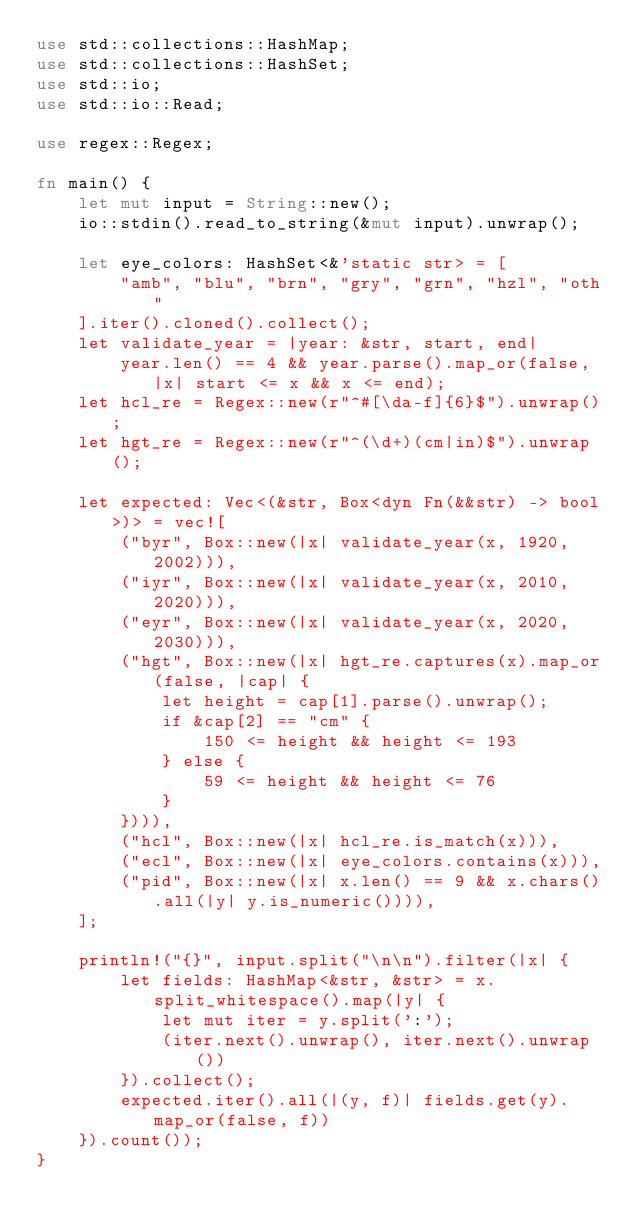Convert code to text. <code><loc_0><loc_0><loc_500><loc_500><_Rust_>use std::collections::HashMap;
use std::collections::HashSet;
use std::io;
use std::io::Read;

use regex::Regex;

fn main() {
    let mut input = String::new();
    io::stdin().read_to_string(&mut input).unwrap();

    let eye_colors: HashSet<&'static str> = [
        "amb", "blu", "brn", "gry", "grn", "hzl", "oth"
    ].iter().cloned().collect();
    let validate_year = |year: &str, start, end| 
        year.len() == 4 && year.parse().map_or(false, |x| start <= x && x <= end);
    let hcl_re = Regex::new(r"^#[\da-f]{6}$").unwrap();
    let hgt_re = Regex::new(r"^(\d+)(cm|in)$").unwrap();

    let expected: Vec<(&str, Box<dyn Fn(&&str) -> bool>)> = vec![
        ("byr", Box::new(|x| validate_year(x, 1920, 2002))),
        ("iyr", Box::new(|x| validate_year(x, 2010, 2020))),
        ("eyr", Box::new(|x| validate_year(x, 2020, 2030))),
        ("hgt", Box::new(|x| hgt_re.captures(x).map_or(false, |cap| {
            let height = cap[1].parse().unwrap();
            if &cap[2] == "cm" {
                150 <= height && height <= 193
            } else {
                59 <= height && height <= 76
            }
        }))),
        ("hcl", Box::new(|x| hcl_re.is_match(x))),
        ("ecl", Box::new(|x| eye_colors.contains(x))),
        ("pid", Box::new(|x| x.len() == 9 && x.chars().all(|y| y.is_numeric()))),
    ];

    println!("{}", input.split("\n\n").filter(|x| {
        let fields: HashMap<&str, &str> = x.split_whitespace().map(|y| {
            let mut iter = y.split(':');
            (iter.next().unwrap(), iter.next().unwrap())
        }).collect();
        expected.iter().all(|(y, f)| fields.get(y).map_or(false, f))
    }).count());
}
</code> 